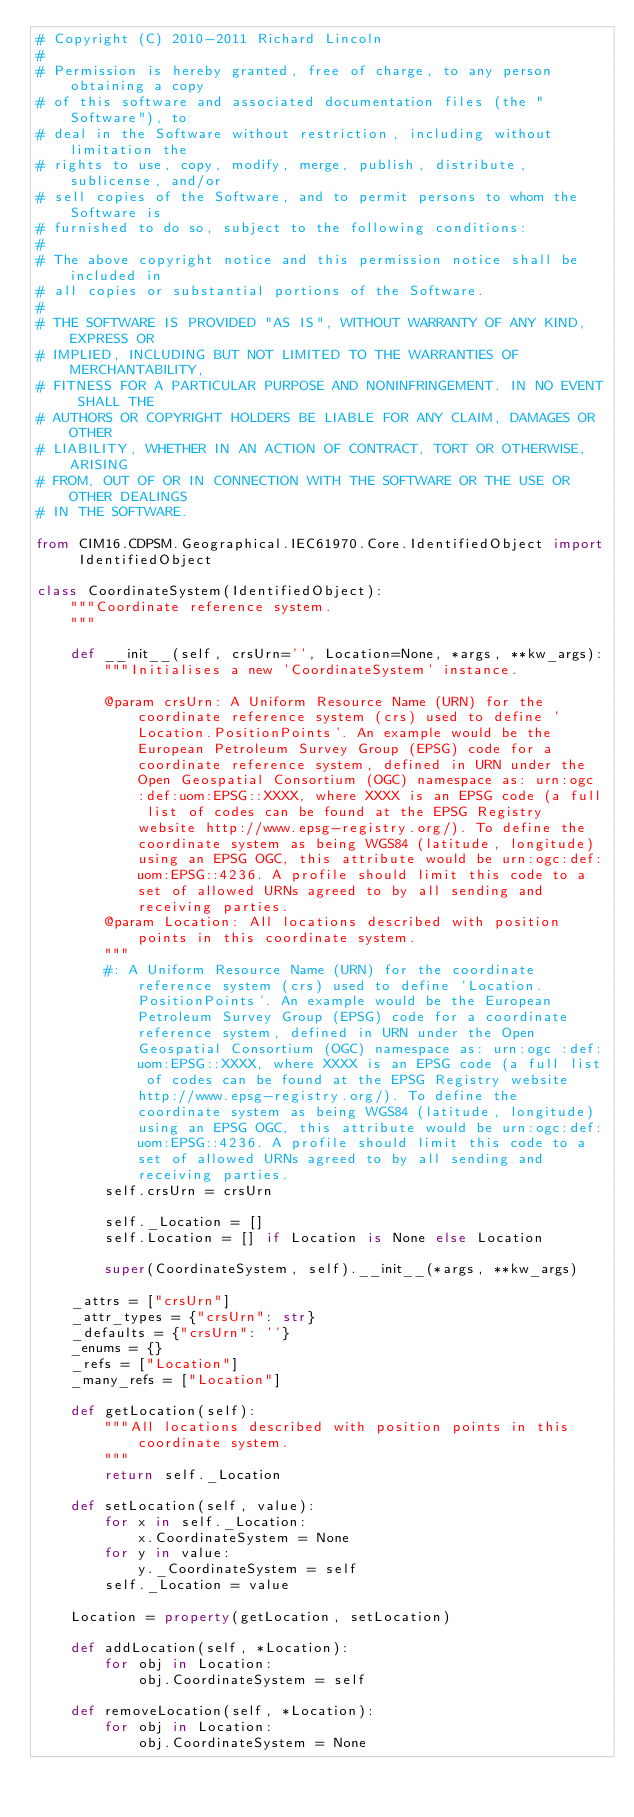<code> <loc_0><loc_0><loc_500><loc_500><_Python_># Copyright (C) 2010-2011 Richard Lincoln
#
# Permission is hereby granted, free of charge, to any person obtaining a copy
# of this software and associated documentation files (the "Software"), to
# deal in the Software without restriction, including without limitation the
# rights to use, copy, modify, merge, publish, distribute, sublicense, and/or
# sell copies of the Software, and to permit persons to whom the Software is
# furnished to do so, subject to the following conditions:
#
# The above copyright notice and this permission notice shall be included in
# all copies or substantial portions of the Software.
#
# THE SOFTWARE IS PROVIDED "AS IS", WITHOUT WARRANTY OF ANY KIND, EXPRESS OR
# IMPLIED, INCLUDING BUT NOT LIMITED TO THE WARRANTIES OF MERCHANTABILITY,
# FITNESS FOR A PARTICULAR PURPOSE AND NONINFRINGEMENT. IN NO EVENT SHALL THE
# AUTHORS OR COPYRIGHT HOLDERS BE LIABLE FOR ANY CLAIM, DAMAGES OR OTHER
# LIABILITY, WHETHER IN AN ACTION OF CONTRACT, TORT OR OTHERWISE, ARISING
# FROM, OUT OF OR IN CONNECTION WITH THE SOFTWARE OR THE USE OR OTHER DEALINGS
# IN THE SOFTWARE.

from CIM16.CDPSM.Geographical.IEC61970.Core.IdentifiedObject import IdentifiedObject

class CoordinateSystem(IdentifiedObject):
    """Coordinate reference system.
    """

    def __init__(self, crsUrn='', Location=None, *args, **kw_args):
        """Initialises a new 'CoordinateSystem' instance.

        @param crsUrn: A Uniform Resource Name (URN) for the coordinate reference system (crs) used to define 'Location.PositionPoints'. An example would be the European Petroleum Survey Group (EPSG) code for a coordinate reference system, defined in URN under the Open Geospatial Consortium (OGC) namespace as: urn:ogc :def:uom:EPSG::XXXX, where XXXX is an EPSG code (a full list of codes can be found at the EPSG Registry website http://www.epsg-registry.org/). To define the coordinate system as being WGS84 (latitude, longitude) using an EPSG OGC, this attribute would be urn:ogc:def:uom:EPSG::4236. A profile should limit this code to a set of allowed URNs agreed to by all sending and receiving parties. 
        @param Location: All locations described with position points in this coordinate system.
        """
        #: A Uniform Resource Name (URN) for the coordinate reference system (crs) used to define 'Location.PositionPoints'. An example would be the European Petroleum Survey Group (EPSG) code for a coordinate reference system, defined in URN under the Open Geospatial Consortium (OGC) namespace as: urn:ogc :def:uom:EPSG::XXXX, where XXXX is an EPSG code (a full list of codes can be found at the EPSG Registry website http://www.epsg-registry.org/). To define the coordinate system as being WGS84 (latitude, longitude) using an EPSG OGC, this attribute would be urn:ogc:def:uom:EPSG::4236. A profile should limit this code to a set of allowed URNs agreed to by all sending and receiving parties.
        self.crsUrn = crsUrn

        self._Location = []
        self.Location = [] if Location is None else Location

        super(CoordinateSystem, self).__init__(*args, **kw_args)

    _attrs = ["crsUrn"]
    _attr_types = {"crsUrn": str}
    _defaults = {"crsUrn": ''}
    _enums = {}
    _refs = ["Location"]
    _many_refs = ["Location"]

    def getLocation(self):
        """All locations described with position points in this coordinate system.
        """
        return self._Location

    def setLocation(self, value):
        for x in self._Location:
            x.CoordinateSystem = None
        for y in value:
            y._CoordinateSystem = self
        self._Location = value

    Location = property(getLocation, setLocation)

    def addLocation(self, *Location):
        for obj in Location:
            obj.CoordinateSystem = self

    def removeLocation(self, *Location):
        for obj in Location:
            obj.CoordinateSystem = None

</code> 